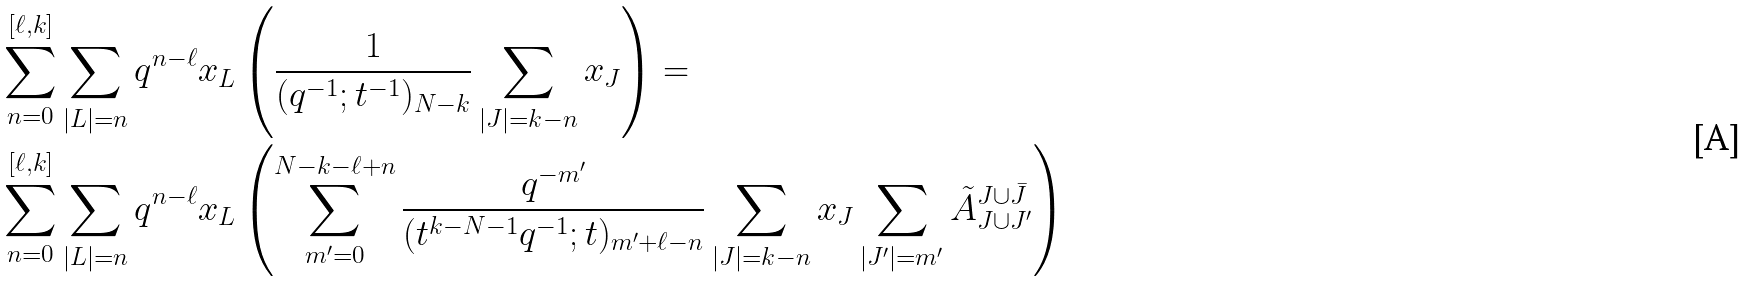Convert formula to latex. <formula><loc_0><loc_0><loc_500><loc_500>& \sum _ { n = 0 } ^ { [ \ell , k ] } \sum _ { | L | = n } q ^ { n - \ell } x _ { L } \left ( \frac { 1 } { ( q ^ { - 1 } ; t ^ { - 1 } ) _ { N - k } } \sum _ { | J | = k - n } x _ { J } \right ) = \\ & \sum _ { n = 0 } ^ { [ \ell , k ] } \sum _ { | L | = n } q ^ { n - \ell } x _ { L } \left ( \sum _ { m ^ { \prime } = 0 } ^ { N - k - \ell + n } \frac { q ^ { - m ^ { \prime } } } { ( t ^ { k - N - 1 } q ^ { - 1 } ; t ) _ { m ^ { \prime } + \ell - n } } \sum _ { | J | = k - n } x _ { J } \sum _ { | J ^ { \prime } | = m ^ { \prime } } \tilde { A } _ { J \cup J ^ { \prime } } ^ { J \cup \bar { J } } \right )</formula> 